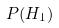Convert formula to latex. <formula><loc_0><loc_0><loc_500><loc_500>P ( H _ { 1 } )</formula> 